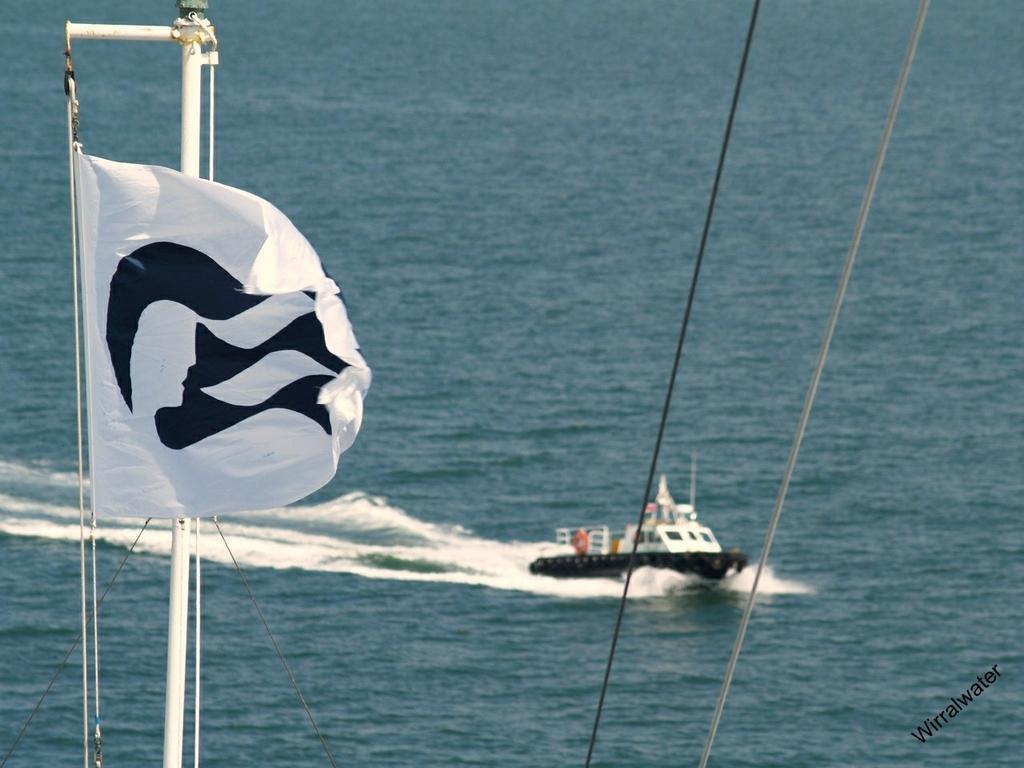Describe this image in one or two sentences. In this image I can see water and a boat in it. I can also see a white flag and a white iron pole. 